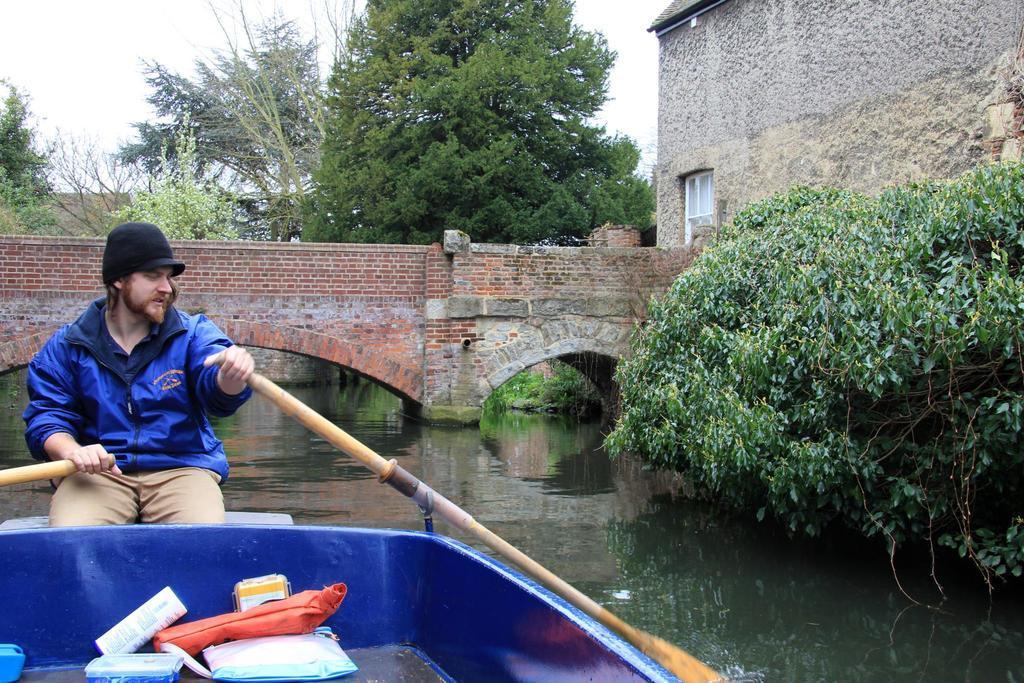In one or two sentences, can you explain what this image depicts? In the foreground area of the image there is a man who is sitting on a boat, on the left side of the image on the water, by holding oars in his hands, there are few boxes in the boat, there are trees, a bridge, and a house in the background area and there is a tree on the right side of the image. 